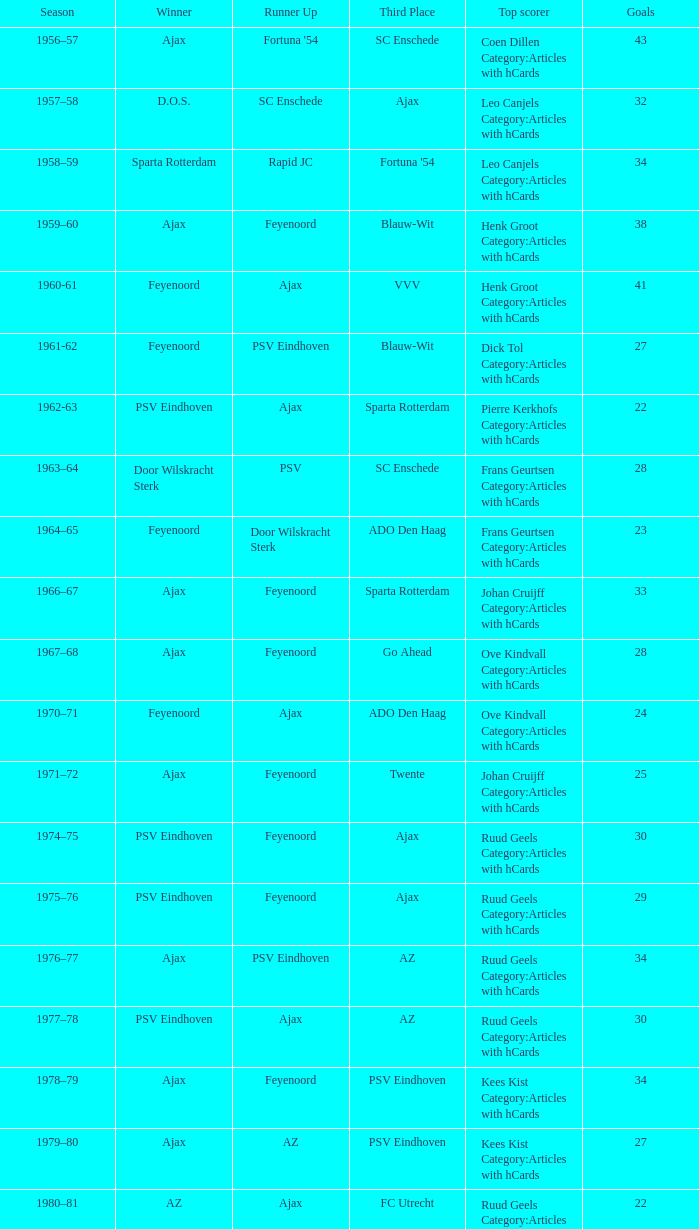If az secures second place and feyenoord ranks third, what is the overall number of winners? 1.0. 